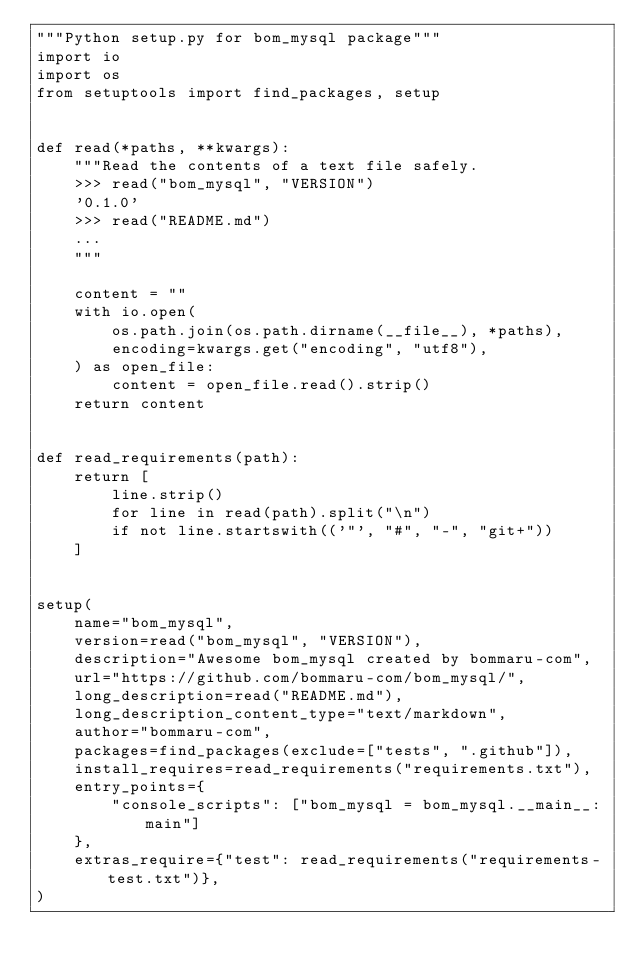<code> <loc_0><loc_0><loc_500><loc_500><_Python_>"""Python setup.py for bom_mysql package"""
import io
import os
from setuptools import find_packages, setup


def read(*paths, **kwargs):
    """Read the contents of a text file safely.
    >>> read("bom_mysql", "VERSION")
    '0.1.0'
    >>> read("README.md")
    ...
    """

    content = ""
    with io.open(
        os.path.join(os.path.dirname(__file__), *paths),
        encoding=kwargs.get("encoding", "utf8"),
    ) as open_file:
        content = open_file.read().strip()
    return content


def read_requirements(path):
    return [
        line.strip()
        for line in read(path).split("\n")
        if not line.startswith(('"', "#", "-", "git+"))
    ]


setup(
    name="bom_mysql",
    version=read("bom_mysql", "VERSION"),
    description="Awesome bom_mysql created by bommaru-com",
    url="https://github.com/bommaru-com/bom_mysql/",
    long_description=read("README.md"),
    long_description_content_type="text/markdown",
    author="bommaru-com",
    packages=find_packages(exclude=["tests", ".github"]),
    install_requires=read_requirements("requirements.txt"),
    entry_points={
        "console_scripts": ["bom_mysql = bom_mysql.__main__:main"]
    },
    extras_require={"test": read_requirements("requirements-test.txt")},
)
</code> 